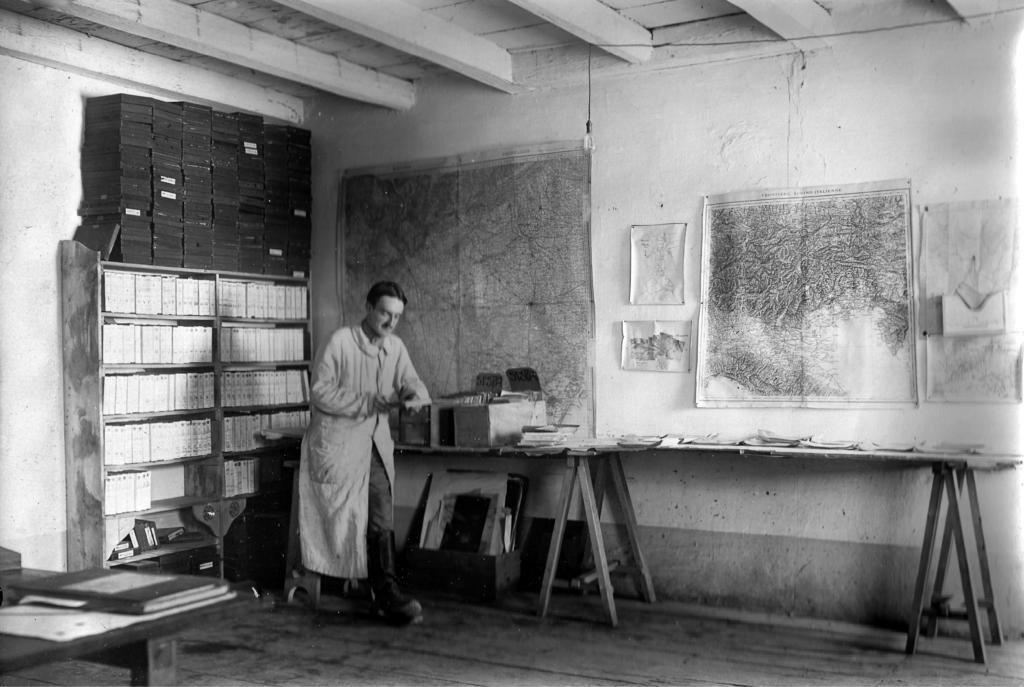What is the main subject of the image? There is a person standing in the image. What is the person holding in the image? The person is holding an object. What can be seen in the background of the image? There are books arranged on a shelf and a map pasted on the wall in the background. How many planes are flying over the person in the image? There are no planes visible in the image. What type of beef is being prepared in the background of the image? There is no beef or any food preparation visible in the image. 